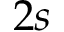<formula> <loc_0><loc_0><loc_500><loc_500>2 s</formula> 